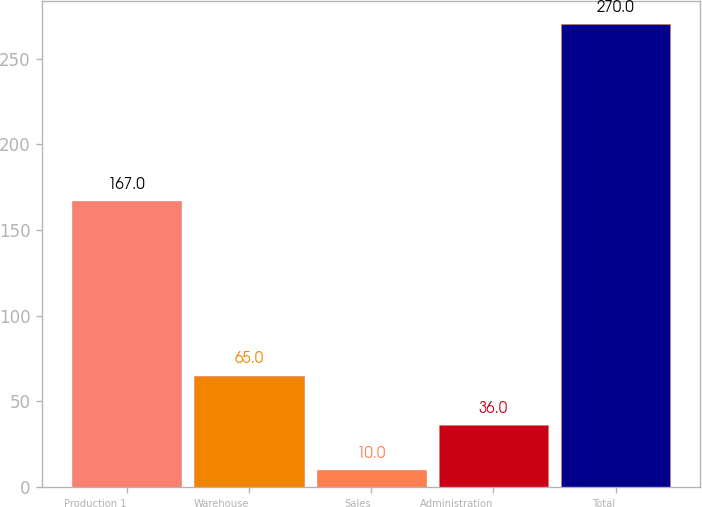Convert chart. <chart><loc_0><loc_0><loc_500><loc_500><bar_chart><fcel>Production 1<fcel>Warehouse<fcel>Sales<fcel>Administration<fcel>Total<nl><fcel>167<fcel>65<fcel>10<fcel>36<fcel>270<nl></chart> 